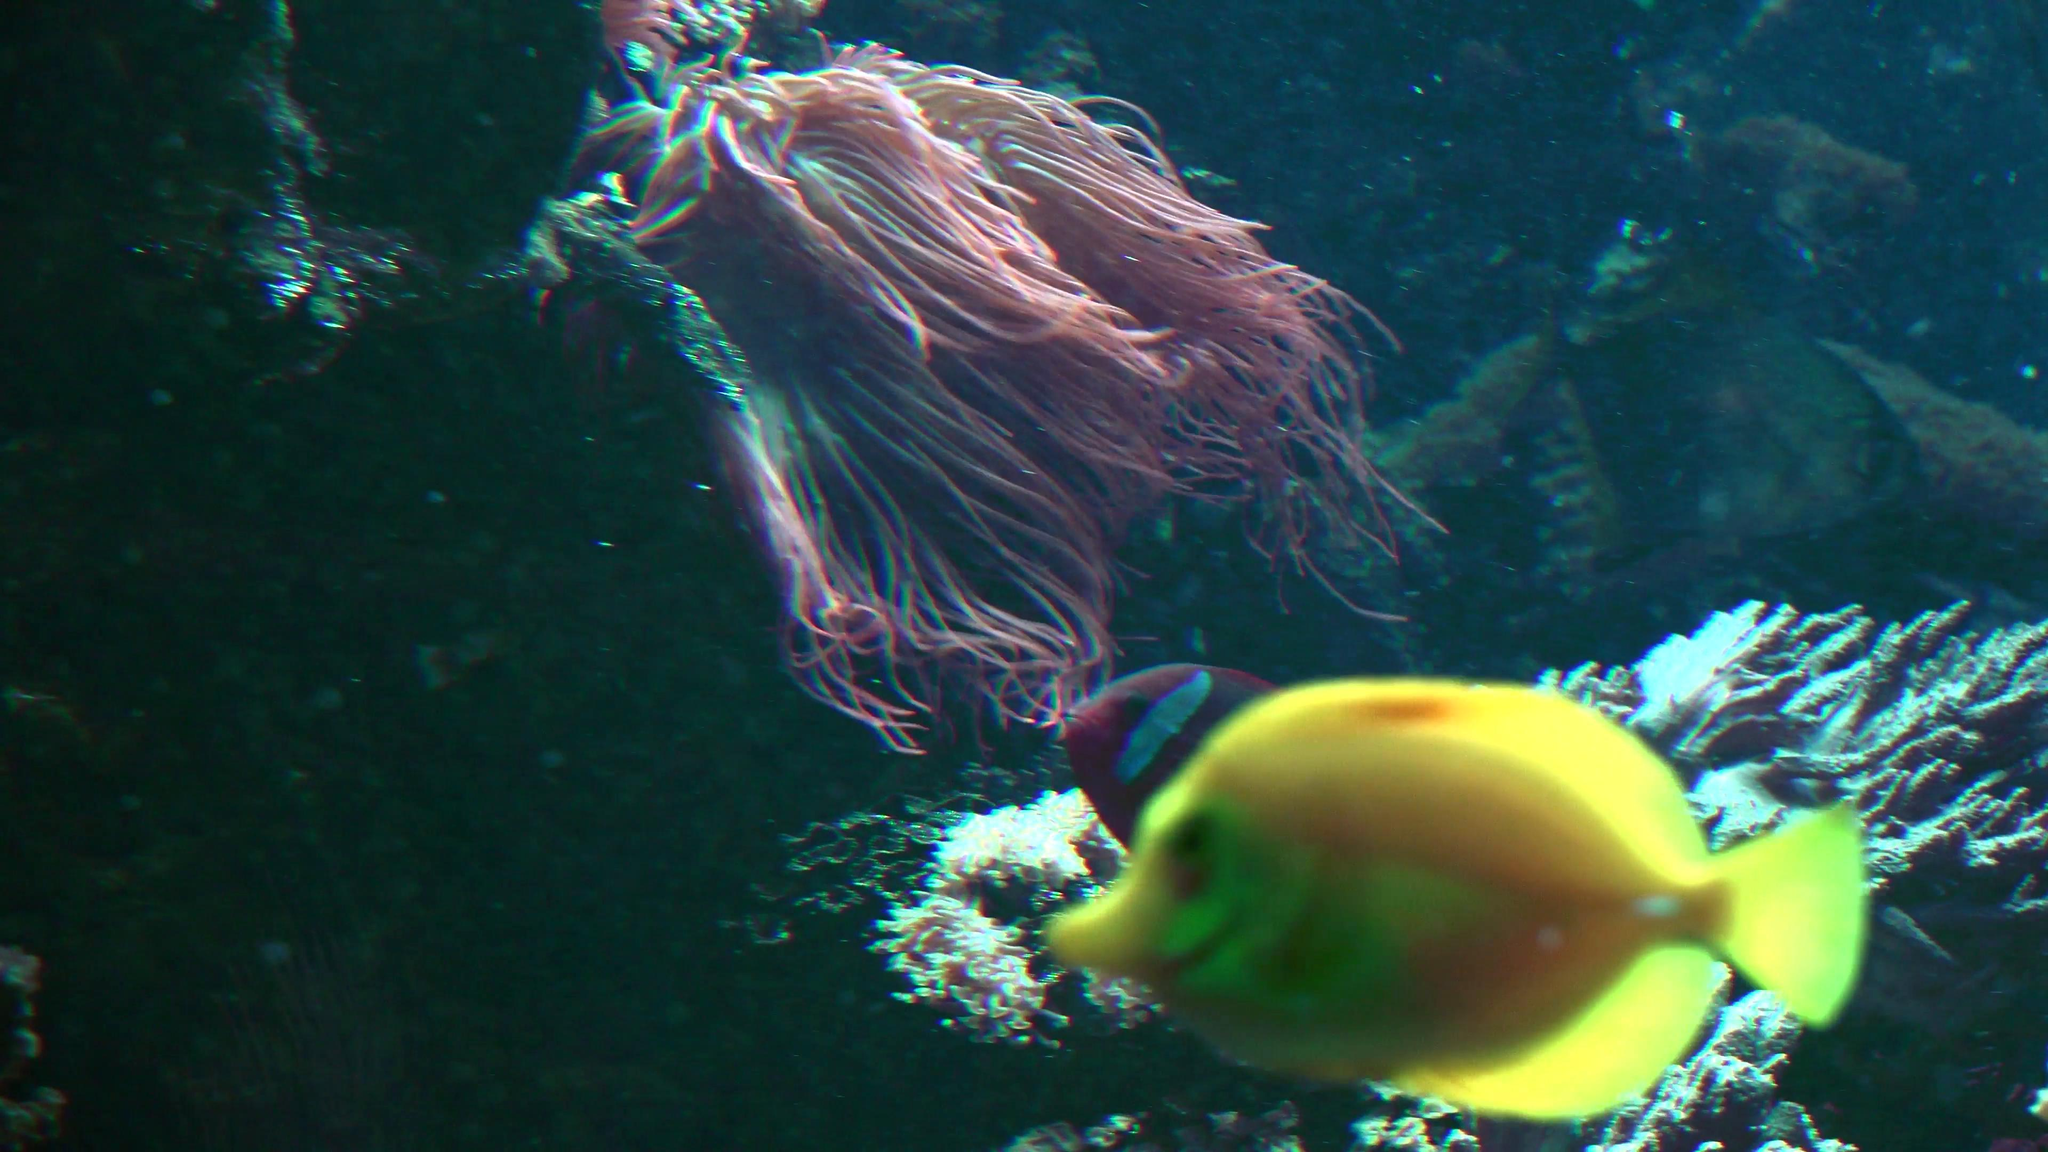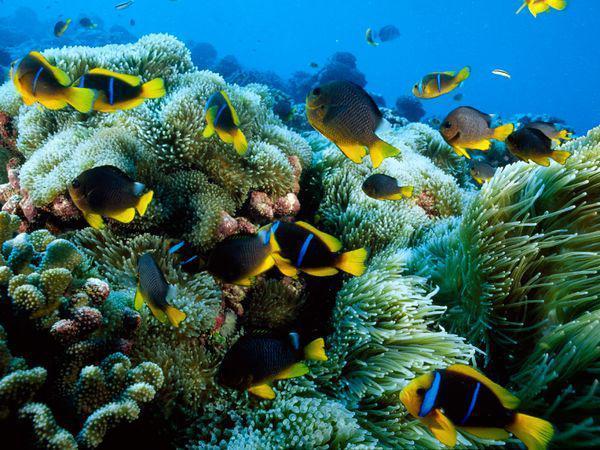The first image is the image on the left, the second image is the image on the right. Examine the images to the left and right. Is the description "One of the two images shows more than one of the same species of free-swimming fish." accurate? Answer yes or no. Yes. The first image is the image on the left, the second image is the image on the right. Evaluate the accuracy of this statement regarding the images: "At least one image shows fish swimming around a sea anemone.". Is it true? Answer yes or no. Yes. 